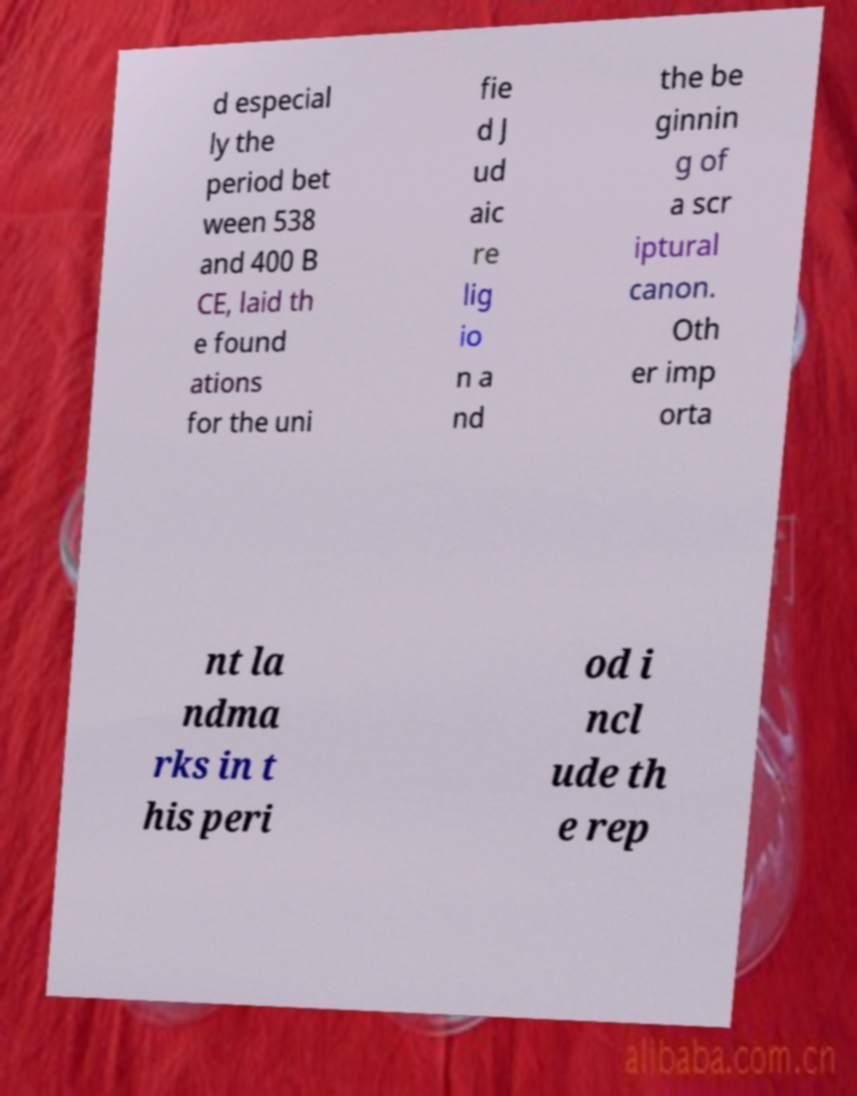Could you assist in decoding the text presented in this image and type it out clearly? d especial ly the period bet ween 538 and 400 B CE, laid th e found ations for the uni fie d J ud aic re lig io n a nd the be ginnin g of a scr iptural canon. Oth er imp orta nt la ndma rks in t his peri od i ncl ude th e rep 